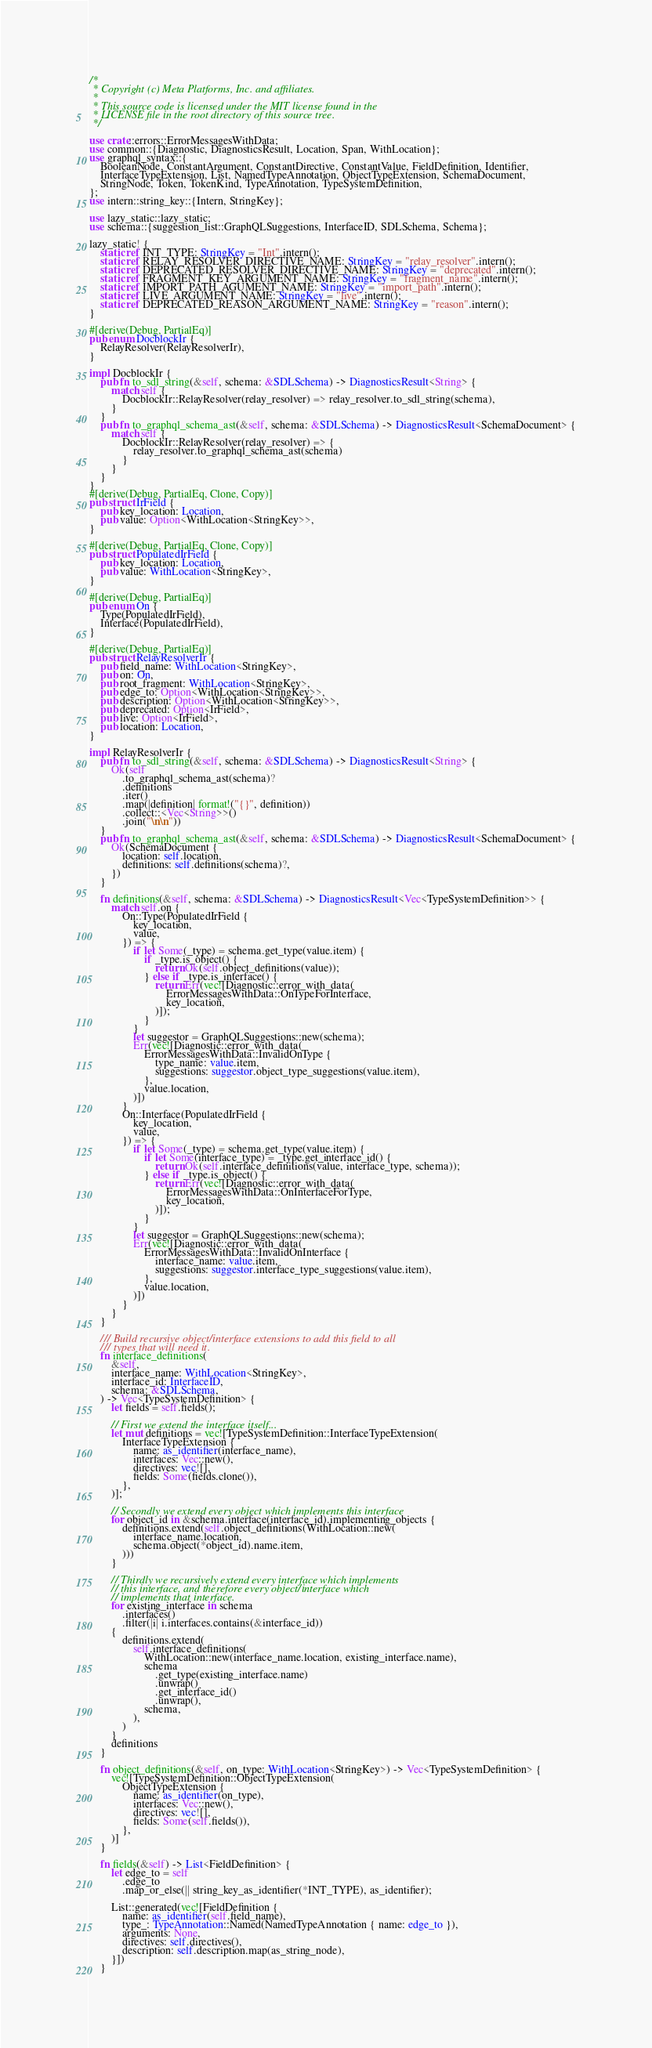Convert code to text. <code><loc_0><loc_0><loc_500><loc_500><_Rust_>/*
 * Copyright (c) Meta Platforms, Inc. and affiliates.
 *
 * This source code is licensed under the MIT license found in the
 * LICENSE file in the root directory of this source tree.
 */

use crate::errors::ErrorMessagesWithData;
use common::{Diagnostic, DiagnosticsResult, Location, Span, WithLocation};
use graphql_syntax::{
    BooleanNode, ConstantArgument, ConstantDirective, ConstantValue, FieldDefinition, Identifier,
    InterfaceTypeExtension, List, NamedTypeAnnotation, ObjectTypeExtension, SchemaDocument,
    StringNode, Token, TokenKind, TypeAnnotation, TypeSystemDefinition,
};
use intern::string_key::{Intern, StringKey};

use lazy_static::lazy_static;
use schema::{suggestion_list::GraphQLSuggestions, InterfaceID, SDLSchema, Schema};

lazy_static! {
    static ref INT_TYPE: StringKey = "Int".intern();
    static ref RELAY_RESOLVER_DIRECTIVE_NAME: StringKey = "relay_resolver".intern();
    static ref DEPRECATED_RESOLVER_DIRECTIVE_NAME: StringKey = "deprecated".intern();
    static ref FRAGMENT_KEY_ARGUMENT_NAME: StringKey = "fragment_name".intern();
    static ref IMPORT_PATH_AGUMENT_NAME: StringKey = "import_path".intern();
    static ref LIVE_ARGUMENT_NAME: StringKey = "live".intern();
    static ref DEPRECATED_REASON_ARGUMENT_NAME: StringKey = "reason".intern();
}

#[derive(Debug, PartialEq)]
pub enum DocblockIr {
    RelayResolver(RelayResolverIr),
}

impl DocblockIr {
    pub fn to_sdl_string(&self, schema: &SDLSchema) -> DiagnosticsResult<String> {
        match self {
            DocblockIr::RelayResolver(relay_resolver) => relay_resolver.to_sdl_string(schema),
        }
    }
    pub fn to_graphql_schema_ast(&self, schema: &SDLSchema) -> DiagnosticsResult<SchemaDocument> {
        match self {
            DocblockIr::RelayResolver(relay_resolver) => {
                relay_resolver.to_graphql_schema_ast(schema)
            }
        }
    }
}
#[derive(Debug, PartialEq, Clone, Copy)]
pub struct IrField {
    pub key_location: Location,
    pub value: Option<WithLocation<StringKey>>,
}

#[derive(Debug, PartialEq, Clone, Copy)]
pub struct PopulatedIrField {
    pub key_location: Location,
    pub value: WithLocation<StringKey>,
}

#[derive(Debug, PartialEq)]
pub enum On {
    Type(PopulatedIrField),
    Interface(PopulatedIrField),
}

#[derive(Debug, PartialEq)]
pub struct RelayResolverIr {
    pub field_name: WithLocation<StringKey>,
    pub on: On,
    pub root_fragment: WithLocation<StringKey>,
    pub edge_to: Option<WithLocation<StringKey>>,
    pub description: Option<WithLocation<StringKey>>,
    pub deprecated: Option<IrField>,
    pub live: Option<IrField>,
    pub location: Location,
}

impl RelayResolverIr {
    pub fn to_sdl_string(&self, schema: &SDLSchema) -> DiagnosticsResult<String> {
        Ok(self
            .to_graphql_schema_ast(schema)?
            .definitions
            .iter()
            .map(|definition| format!("{}", definition))
            .collect::<Vec<String>>()
            .join("\n\n"))
    }
    pub fn to_graphql_schema_ast(&self, schema: &SDLSchema) -> DiagnosticsResult<SchemaDocument> {
        Ok(SchemaDocument {
            location: self.location,
            definitions: self.definitions(schema)?,
        })
    }

    fn definitions(&self, schema: &SDLSchema) -> DiagnosticsResult<Vec<TypeSystemDefinition>> {
        match self.on {
            On::Type(PopulatedIrField {
                key_location,
                value,
            }) => {
                if let Some(_type) = schema.get_type(value.item) {
                    if _type.is_object() {
                        return Ok(self.object_definitions(value));
                    } else if _type.is_interface() {
                        return Err(vec![Diagnostic::error_with_data(
                            ErrorMessagesWithData::OnTypeForInterface,
                            key_location,
                        )]);
                    }
                }
                let suggestor = GraphQLSuggestions::new(schema);
                Err(vec![Diagnostic::error_with_data(
                    ErrorMessagesWithData::InvalidOnType {
                        type_name: value.item,
                        suggestions: suggestor.object_type_suggestions(value.item),
                    },
                    value.location,
                )])
            }
            On::Interface(PopulatedIrField {
                key_location,
                value,
            }) => {
                if let Some(_type) = schema.get_type(value.item) {
                    if let Some(interface_type) = _type.get_interface_id() {
                        return Ok(self.interface_definitions(value, interface_type, schema));
                    } else if _type.is_object() {
                        return Err(vec![Diagnostic::error_with_data(
                            ErrorMessagesWithData::OnInterfaceForType,
                            key_location,
                        )]);
                    }
                }
                let suggestor = GraphQLSuggestions::new(schema);
                Err(vec![Diagnostic::error_with_data(
                    ErrorMessagesWithData::InvalidOnInterface {
                        interface_name: value.item,
                        suggestions: suggestor.interface_type_suggestions(value.item),
                    },
                    value.location,
                )])
            }
        }
    }

    /// Build recursive object/interface extensions to add this field to all
    /// types that will need it.
    fn interface_definitions(
        &self,
        interface_name: WithLocation<StringKey>,
        interface_id: InterfaceID,
        schema: &SDLSchema,
    ) -> Vec<TypeSystemDefinition> {
        let fields = self.fields();

        // First we extend the interface itself...
        let mut definitions = vec![TypeSystemDefinition::InterfaceTypeExtension(
            InterfaceTypeExtension {
                name: as_identifier(interface_name),
                interfaces: Vec::new(),
                directives: vec![],
                fields: Some(fields.clone()),
            },
        )];

        // Secondly we extend every object which implements this interface
        for object_id in &schema.interface(interface_id).implementing_objects {
            definitions.extend(self.object_definitions(WithLocation::new(
                interface_name.location,
                schema.object(*object_id).name.item,
            )))
        }

        // Thirdly we recursively extend every interface which implements
        // this interface, and therefore every object/interface which
        // implements that interface.
        for existing_interface in schema
            .interfaces()
            .filter(|i| i.interfaces.contains(&interface_id))
        {
            definitions.extend(
                self.interface_definitions(
                    WithLocation::new(interface_name.location, existing_interface.name),
                    schema
                        .get_type(existing_interface.name)
                        .unwrap()
                        .get_interface_id()
                        .unwrap(),
                    schema,
                ),
            )
        }
        definitions
    }

    fn object_definitions(&self, on_type: WithLocation<StringKey>) -> Vec<TypeSystemDefinition> {
        vec![TypeSystemDefinition::ObjectTypeExtension(
            ObjectTypeExtension {
                name: as_identifier(on_type),
                interfaces: Vec::new(),
                directives: vec![],
                fields: Some(self.fields()),
            },
        )]
    }

    fn fields(&self) -> List<FieldDefinition> {
        let edge_to = self
            .edge_to
            .map_or_else(|| string_key_as_identifier(*INT_TYPE), as_identifier);

        List::generated(vec![FieldDefinition {
            name: as_identifier(self.field_name),
            type_: TypeAnnotation::Named(NamedTypeAnnotation { name: edge_to }),
            arguments: None,
            directives: self.directives(),
            description: self.description.map(as_string_node),
        }])
    }
</code> 